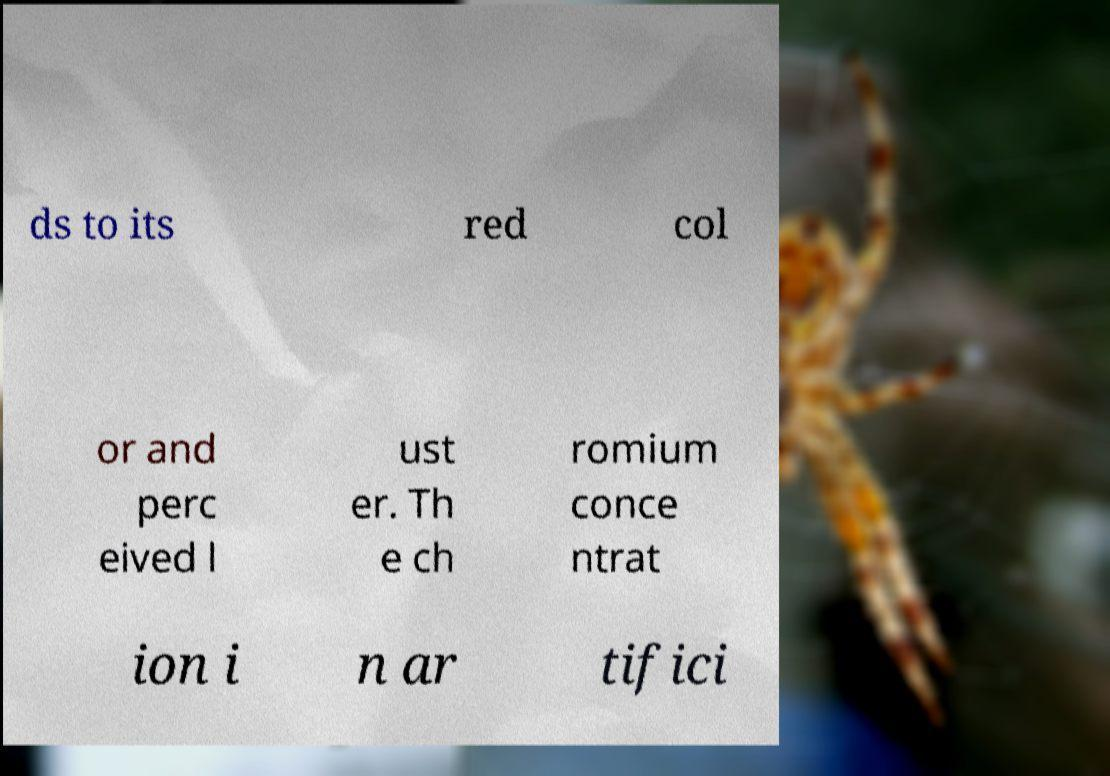There's text embedded in this image that I need extracted. Can you transcribe it verbatim? ds to its red col or and perc eived l ust er. Th e ch romium conce ntrat ion i n ar tifici 